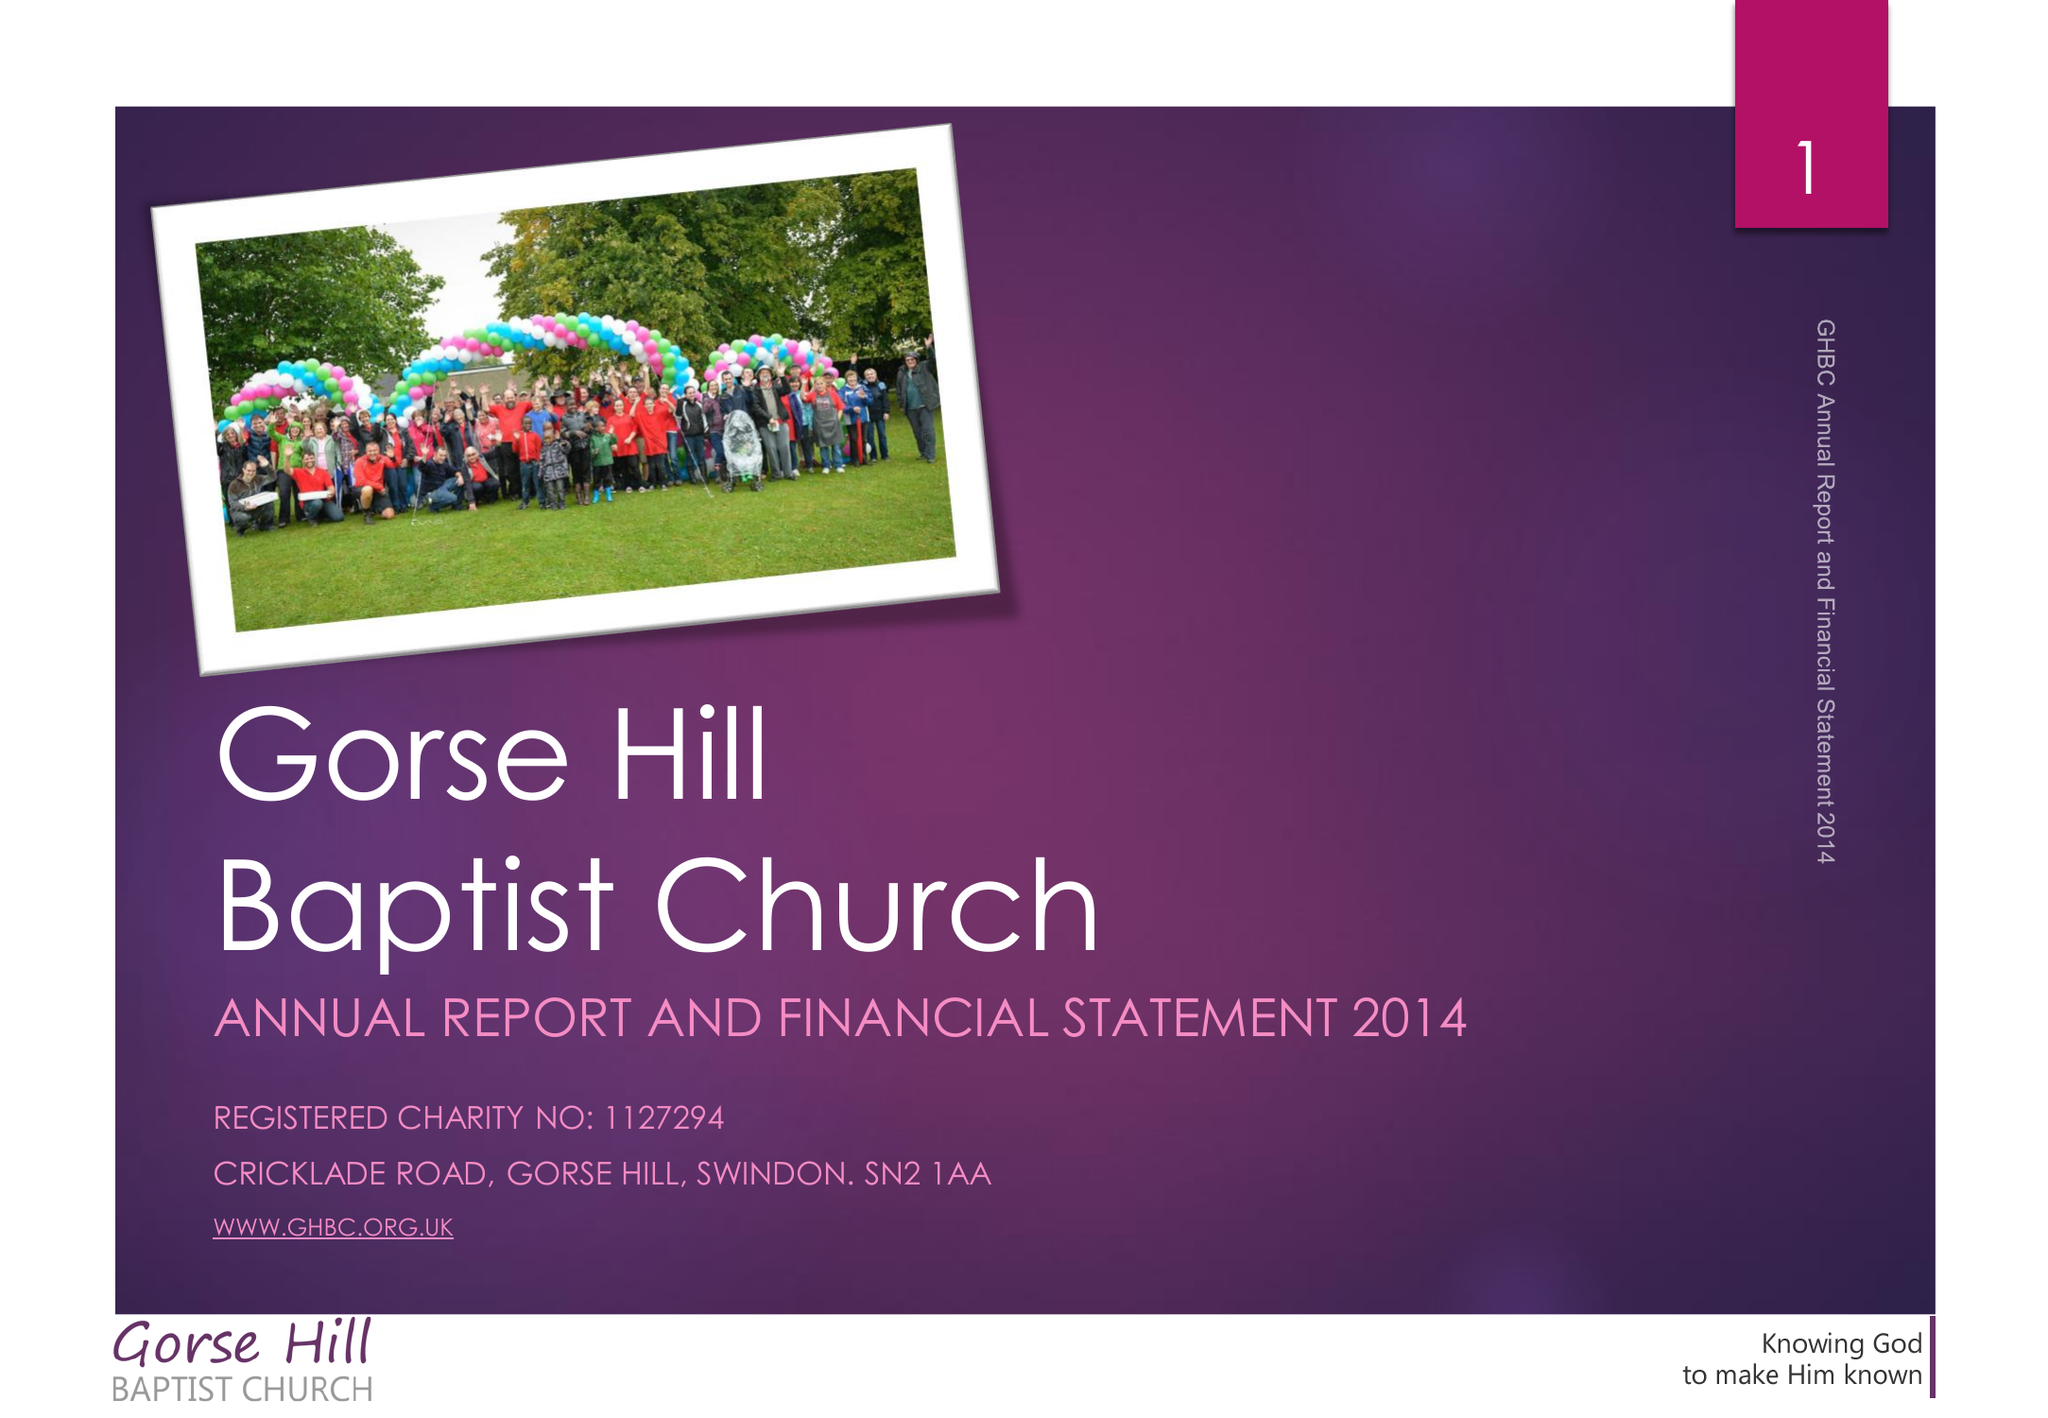What is the value for the address__post_town?
Answer the question using a single word or phrase. SWINDON 